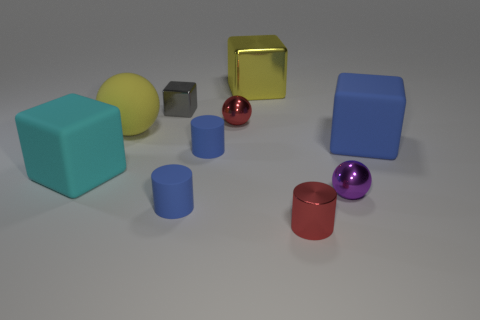Subtract all red blocks. Subtract all brown cylinders. How many blocks are left? 4 Subtract all blocks. How many objects are left? 6 Add 2 purple objects. How many purple objects exist? 3 Subtract 1 red balls. How many objects are left? 9 Subtract all small red metallic spheres. Subtract all large yellow shiny objects. How many objects are left? 8 Add 8 tiny metallic balls. How many tiny metallic balls are left? 10 